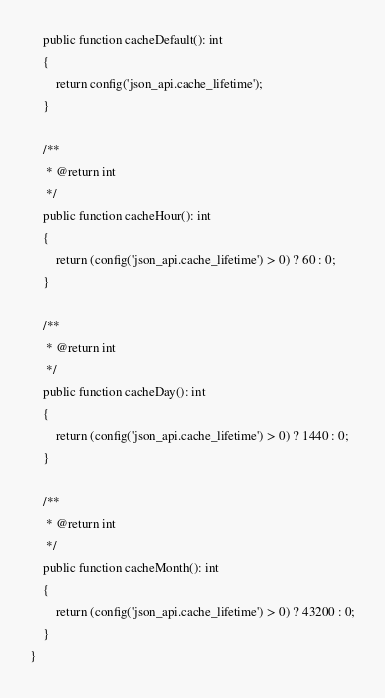Convert code to text. <code><loc_0><loc_0><loc_500><loc_500><_PHP_>    public function cacheDefault(): int
    {
        return config('json_api.cache_lifetime');
    }

    /**
     * @return int
     */
    public function cacheHour(): int
    {
        return (config('json_api.cache_lifetime') > 0) ? 60 : 0;
    }

    /**
     * @return int
     */
    public function cacheDay(): int
    {
        return (config('json_api.cache_lifetime') > 0) ? 1440 : 0;
    }

    /**
     * @return int
     */
    public function cacheMonth(): int
    {
        return (config('json_api.cache_lifetime') > 0) ? 43200 : 0;
    }
}
</code> 